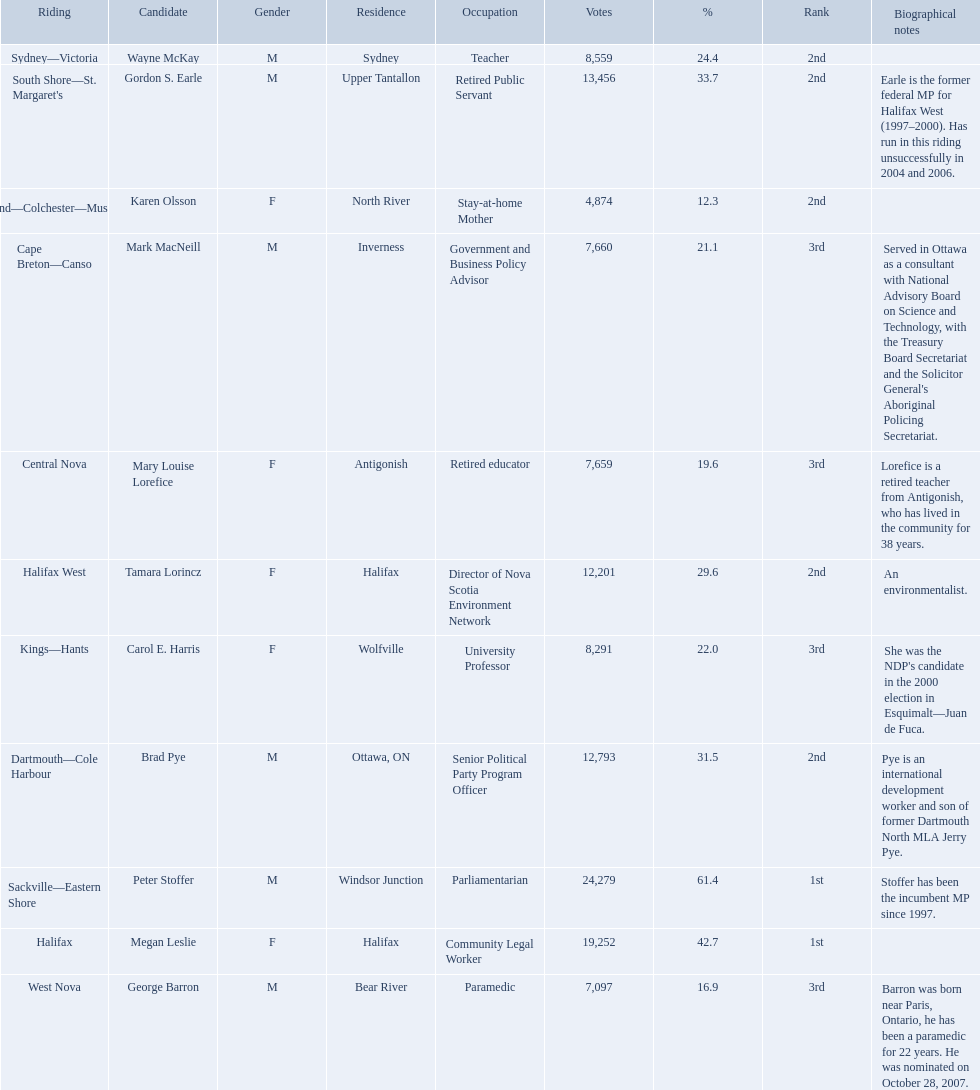Who were all of the new democratic party candidates during the 2008 canadian federal election? Mark MacNeill, Mary Louise Lorefice, Karen Olsson, Brad Pye, Megan Leslie, Tamara Lorincz, Carol E. Harris, Peter Stoffer, Gordon S. Earle, Wayne McKay, George Barron. And between mark macneill and karen olsson, which candidate received more votes? Mark MacNeill. 